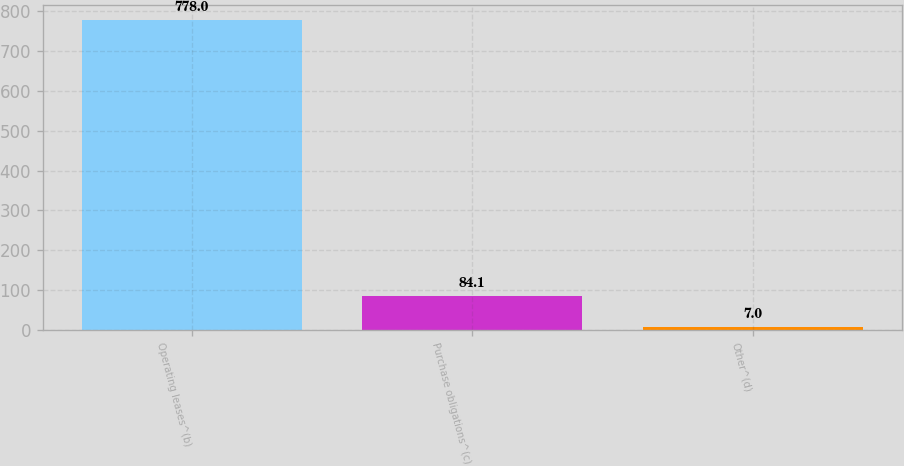<chart> <loc_0><loc_0><loc_500><loc_500><bar_chart><fcel>Operating leases^(b)<fcel>Purchase obligations^(c)<fcel>Other^(d)<nl><fcel>778<fcel>84.1<fcel>7<nl></chart> 